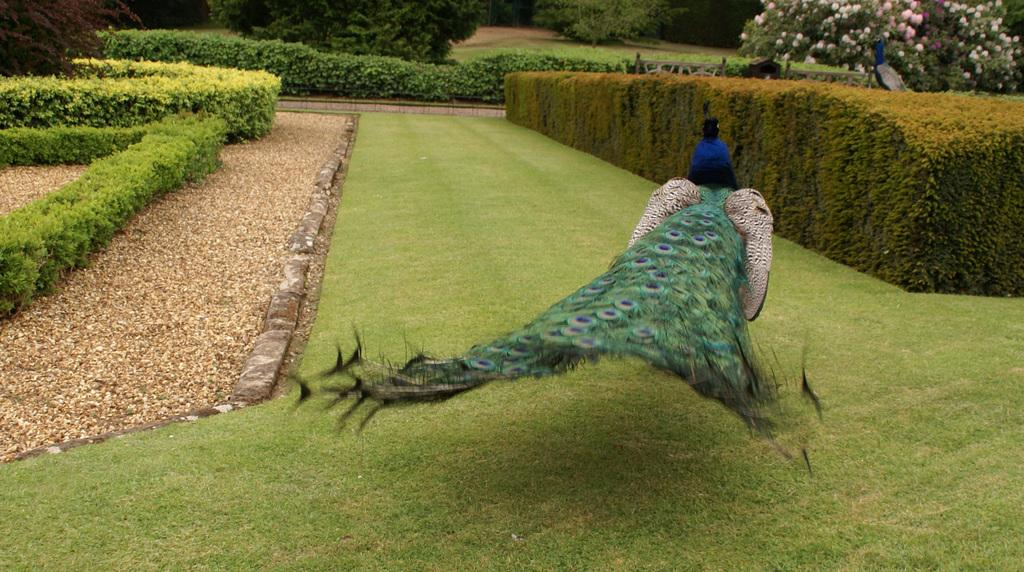What type of animals are in the image? There are peacocks in the image. What is on the ground in the image? Grass is visible on the ground. What can be seen on both sides of the image? There are bushes visible on both sides of the image. What is visible in the background of the image? There are plants in the background of the image. What type of jewel can be seen in the image? There is no jewel present in the image; it features peacocks, grass, bushes, and plants. 